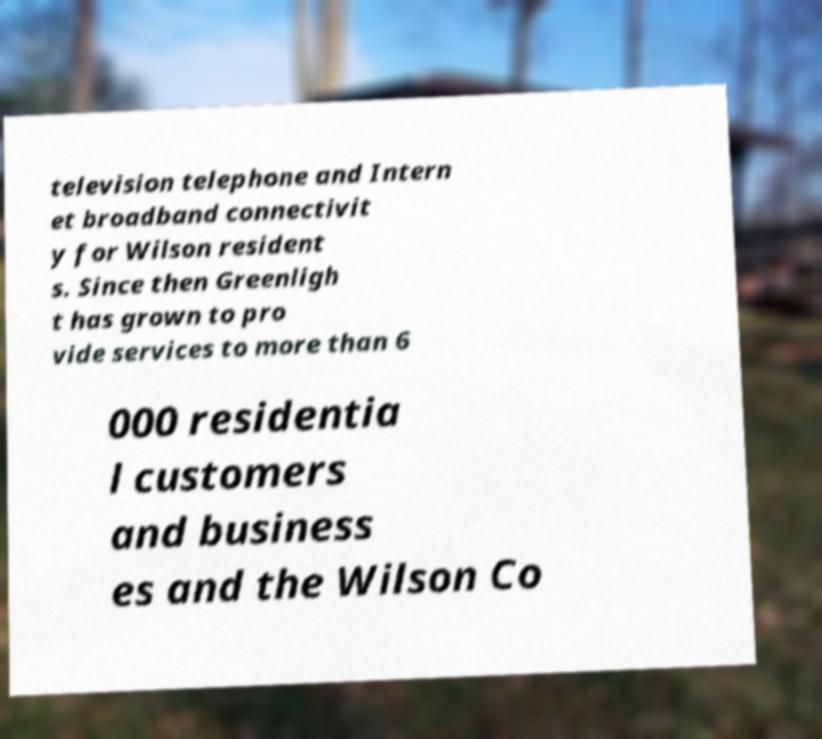Can you read and provide the text displayed in the image?This photo seems to have some interesting text. Can you extract and type it out for me? television telephone and Intern et broadband connectivit y for Wilson resident s. Since then Greenligh t has grown to pro vide services to more than 6 000 residentia l customers and business es and the Wilson Co 